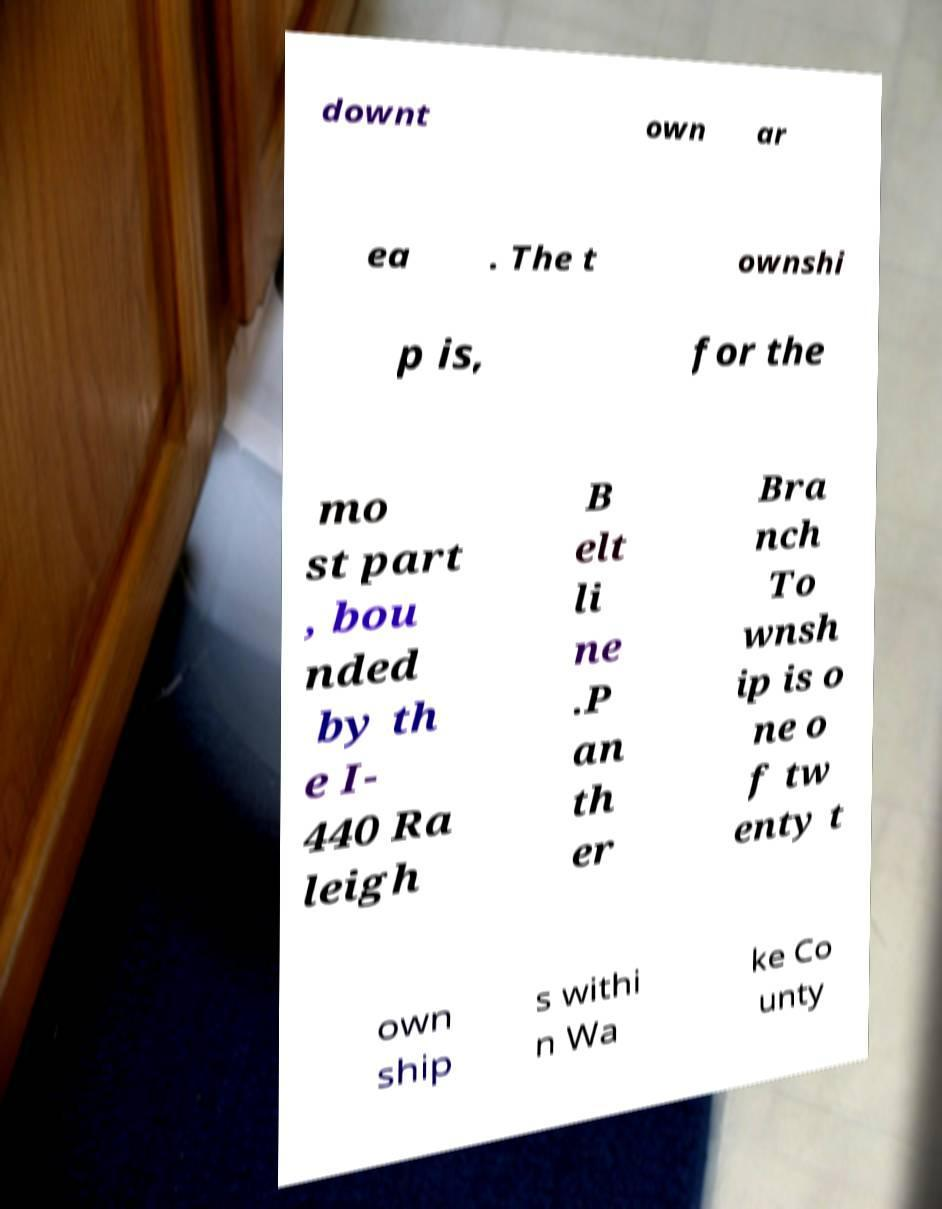What messages or text are displayed in this image? I need them in a readable, typed format. downt own ar ea . The t ownshi p is, for the mo st part , bou nded by th e I- 440 Ra leigh B elt li ne .P an th er Bra nch To wnsh ip is o ne o f tw enty t own ship s withi n Wa ke Co unty 